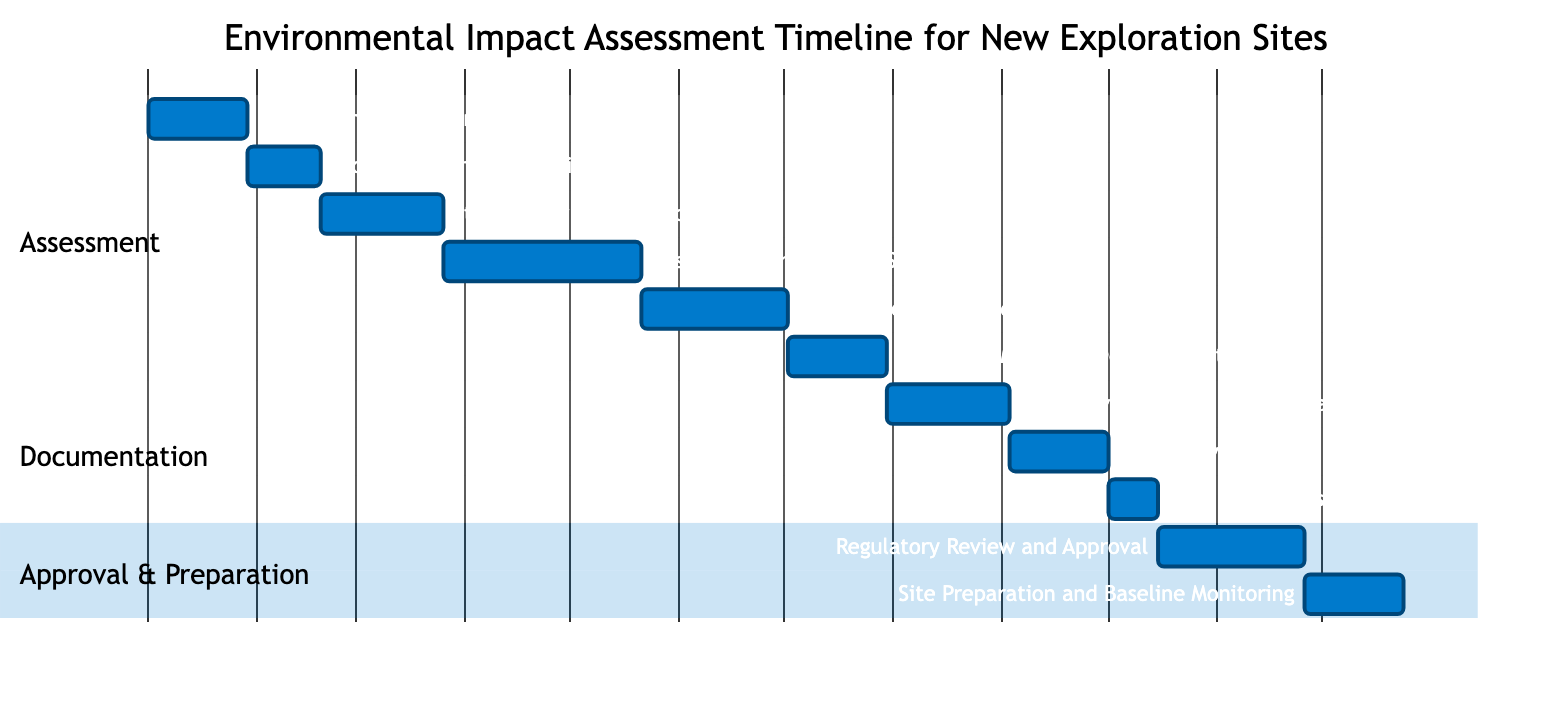What is the duration of the "Stakeholder Consultation" task? The "Stakeholder Consultation" task is displayed directly in the diagram with a length of 5 weeks, which is specified in the duration section for that task.
Answer: 5 weeks What task is dependent on "Impact Prediction and Analysis"? By examining the dependencies in the Gantt Chart, it shows that "Mitigation Measures Development" is the task that follows "Impact Prediction and Analysis," indicating that it depends on its completion.
Answer: Mitigation Measures Development How many total tasks are there in the timeline? To find the total number of tasks, we can count each task listed in the Gantt Chart: there are 11 distinct tasks shown throughout various sections.
Answer: 11 What is the duration of the "Final EIS Submission" task? The "Final EIS Submission" is shown in the Gantt Chart with a specified duration of 2 weeks, directly indicated next to that task in the timeline.
Answer: 2 weeks Which task has the longest duration? By comparing the durations of all the tasks, "Baseline Environmental Studies" has the longest duration, listed at 8 weeks in the diagram.
Answer: Baseline Environmental Studies What is the timeline for public review after the EIS draft? The Gantt Chart illustrates that the "Public Review Period" follows the "Draft Environmental Impact Statement" and lasts for 4 weeks, thus indicating the public review occurs right after that draft is available.
Answer: 4 weeks How many weeks does the entire assessment section take? To calculate the total duration of the assessment section, we add the durations of each task in that section, which totals up to 36 weeks when the durations are summed: 4 + 3 + 5 + 8 + 6 + 4.
Answer: 36 weeks Which task follows the "Regulatory Review and Approval"? By looking at the flow of the tasks in the Gantt Chart, the task that directly follows "Regulatory Review and Approval" is "Site Preparation and Baseline Monitoring," confirming this relationship in the diagram's structure.
Answer: Site Preparation and Baseline Monitoring What is the total duration for the documentation section? The documentation section's tasks consist of "Draft Environmental Impact Statement," "Public Review Period," and "Final EIS Submission." Adding their respective durations (5 + 4 + 2) results in 11 weeks for the documentation section.
Answer: 11 weeks 